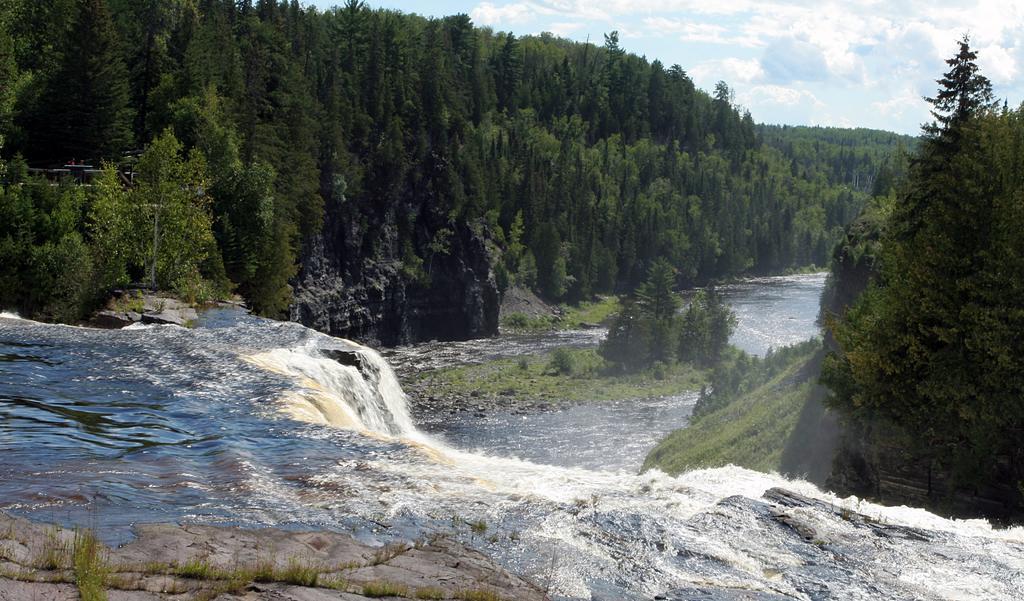Describe this image in one or two sentences. In this image there is a waterfall, in the background of the image there are rocks and trees. 